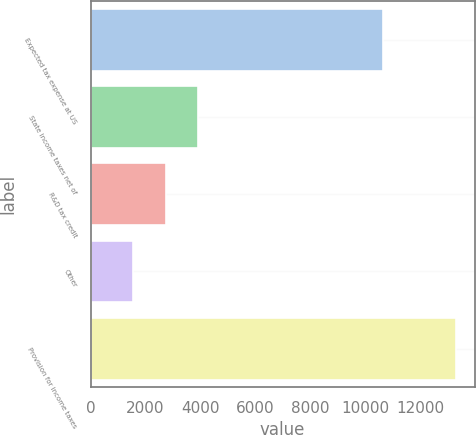Convert chart. <chart><loc_0><loc_0><loc_500><loc_500><bar_chart><fcel>Expected tax expense at US<fcel>State income taxes net of<fcel>R&D tax credit<fcel>Other<fcel>Provision for income taxes<nl><fcel>10667<fcel>3905.6<fcel>2727.8<fcel>1550<fcel>13328<nl></chart> 